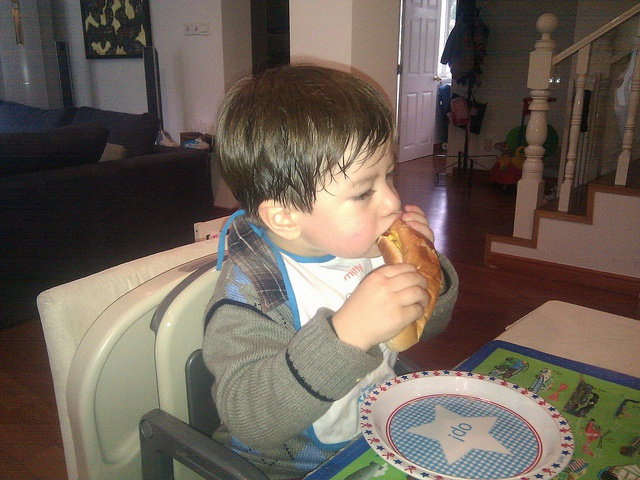Describe the objects in this image and their specific colors. I can see people in gray, darkgray, and tan tones, dining table in gray, darkgray, and darkgreen tones, chair in gray, darkgray, and tan tones, couch in gray and black tones, and sandwich in gray, tan, brown, and salmon tones in this image. 